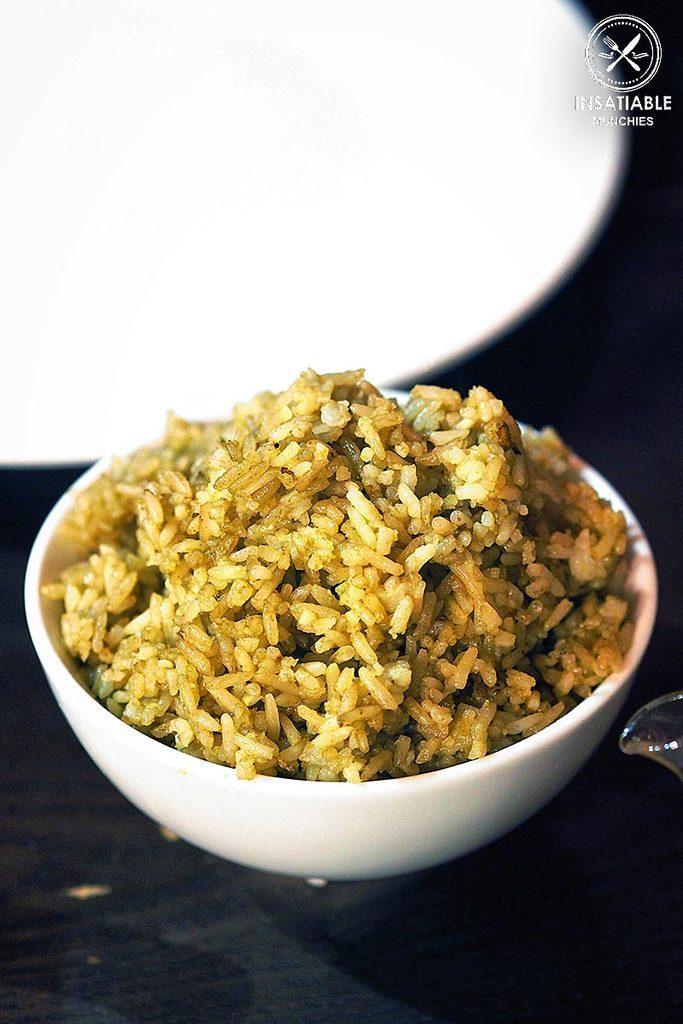Could you give a brief overview of what you see in this image? In this image we can see a bowl containing food is placed on the surface. In the background, we can see bowl, plate and a logo with some text. 